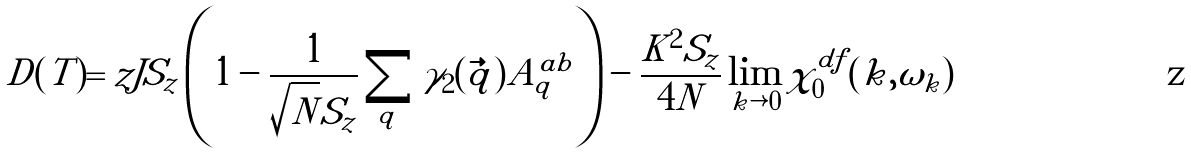Convert formula to latex. <formula><loc_0><loc_0><loc_500><loc_500>\tilde { D } ( T ) = z J S _ { z } \left ( 1 - \frac { 1 } { \sqrt { N } S _ { z } } \sum _ { q } \gamma _ { 2 } ( \vec { q } ) A ^ { a b } _ { q } \right ) - \frac { K ^ { 2 } S _ { z } } { 4 N } \lim _ { k \rightarrow 0 } \chi ^ { d f } _ { 0 } ( k , \omega _ { k } )</formula> 